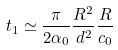Convert formula to latex. <formula><loc_0><loc_0><loc_500><loc_500>t _ { 1 } \simeq \frac { \pi } { 2 \alpha _ { 0 } } \frac { R ^ { 2 } } { d ^ { 2 } } \frac { R } { c _ { 0 } }</formula> 